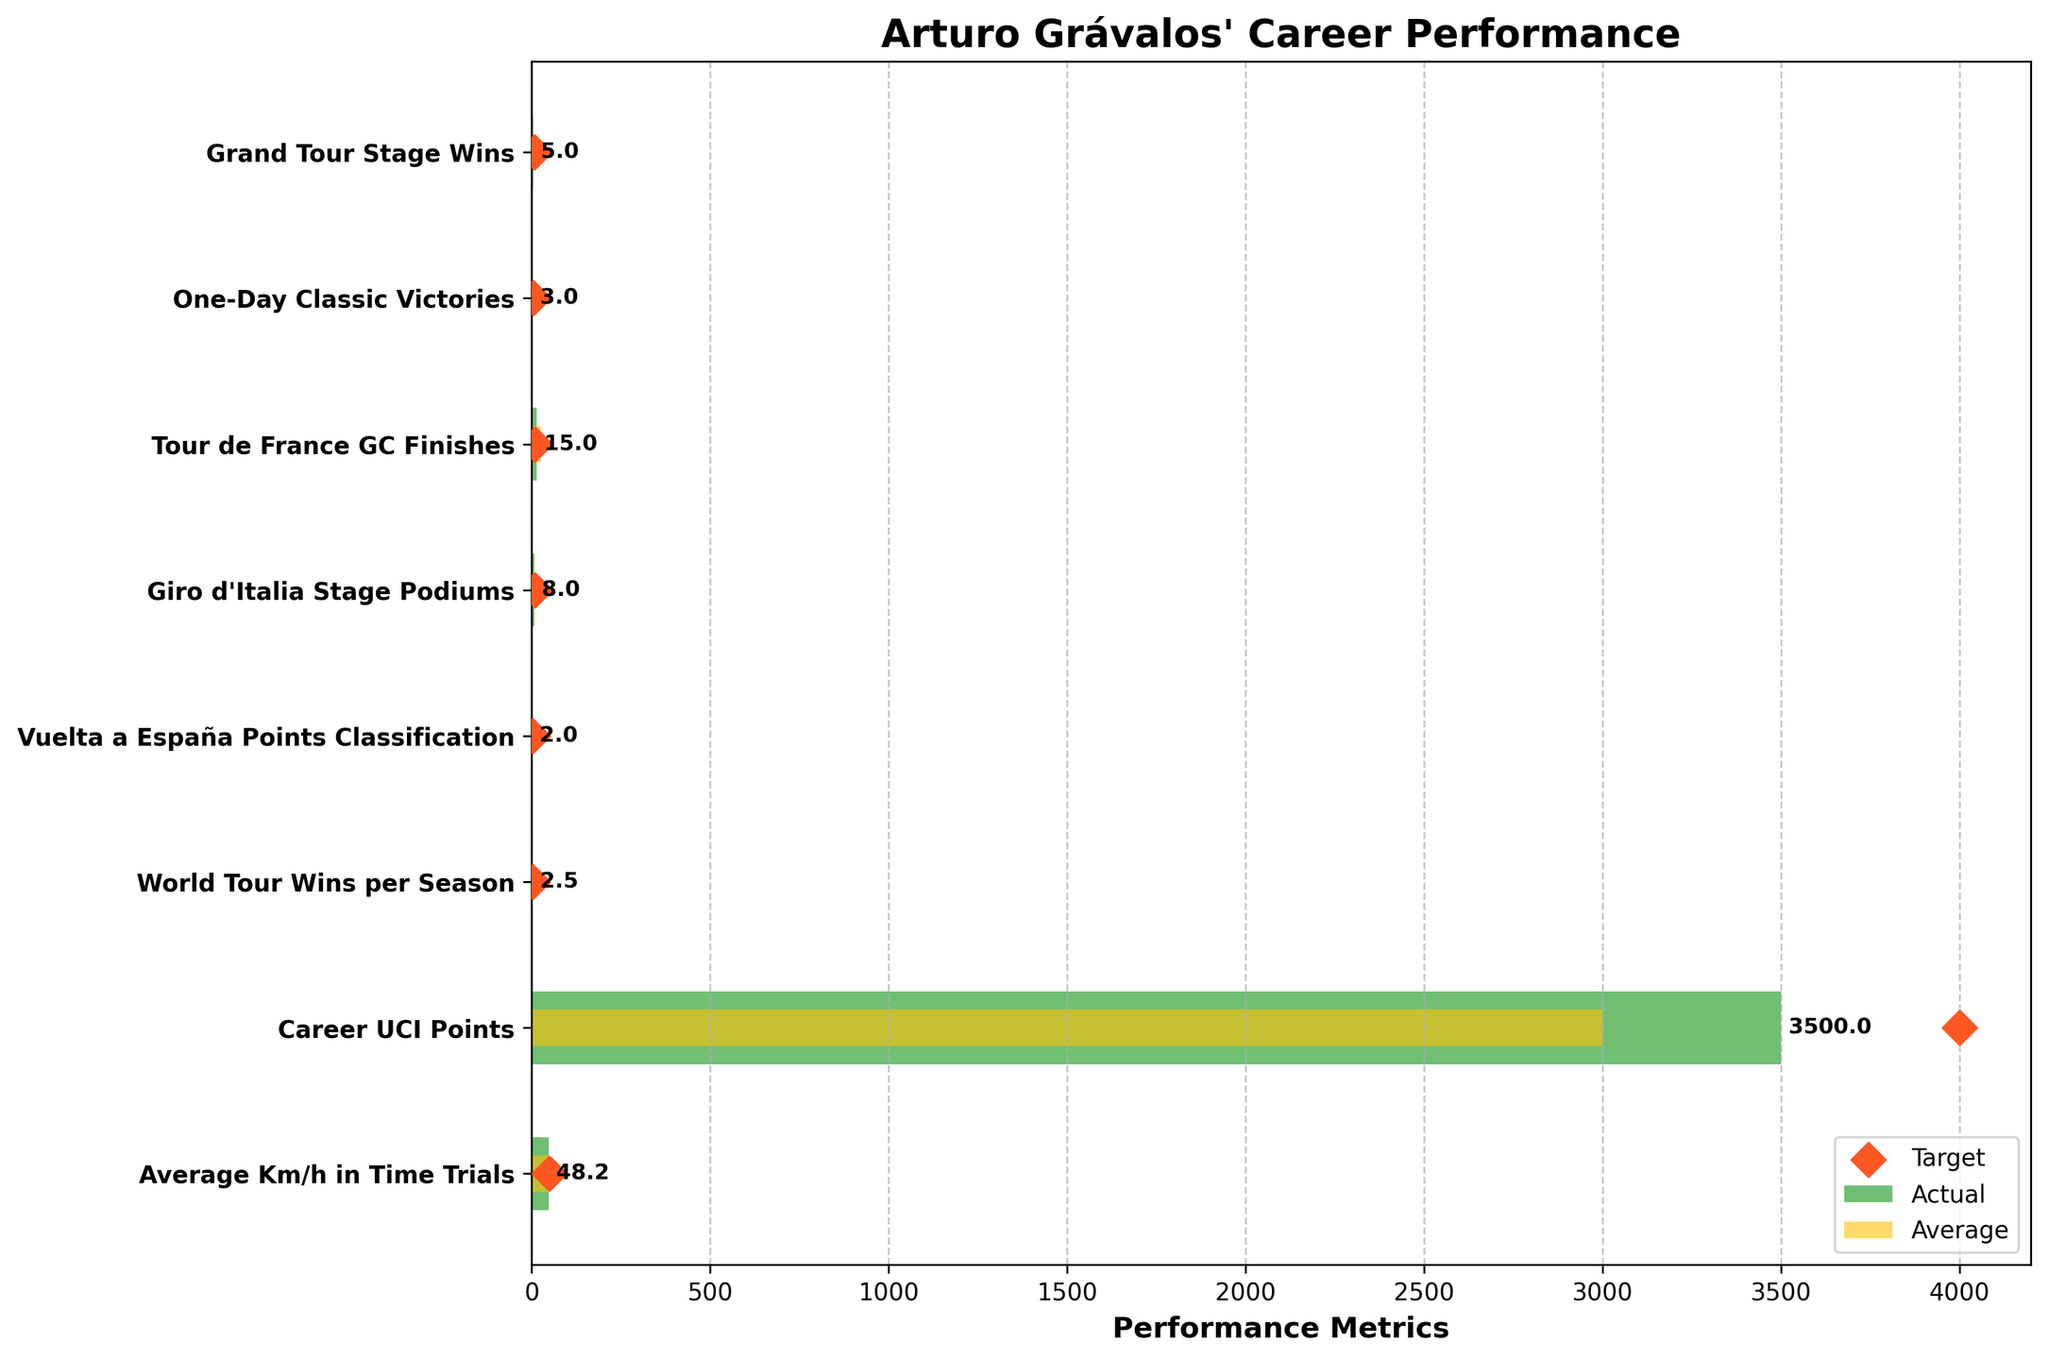what's the title of the figure? The title of the figure is displayed at the top and reads "Arturo Grávalos' Career Performance." Simply reading this text will provide the answer.
Answer: Arturo Grávalos' Career Performance How many performance metrics are shown on the Y-axis? Count the number of categories listed on the Y-axis. The categories appear as the labeled rows on the plot.
Answer: 8 What's the actual number of Grand Tour Stage Wins achieved by Arturo? Locate the "Grand Tour Stage Wins" on the Y-axis and then look at the length of the green bar labeled 'Actual' for this category.
Answer: 5 How many more Giro d'Italia Stage Podiums does Arturo need to reach his target? Look at the actual value (green bar) and the target value (red diamond) for "Giro d'Italia Stage Podiums." Subtract the actual value from the target value (10 - 8).
Answer: 2 In which performance metric did Arturo outperform his average competitor the most? For each category, compare the length of the green bar (Actual) with the yellow bar (Average). The biggest positive difference indicates the most outperformance. This is found by checking visually each of the metrics.
Answer: Tour de France GC Finishes Which metric has the closest actual performance to Arturo's target? Calculate the absolute differences between the actual values (green bars) and target values (red diamonds) for each category. The category with the smallest difference is the answer.
Answer: Average Km/h in Time Trials How many more career UCI points does Arturo need to match his target? Look at the actual value (green bar) and the target value (red diamond) for "Career UCI Points." Subtract the actual value from the target value (4000 - 3500).
Answer: 500 Which category did Arturo exceed his target? Identify the category where the green bar (actual) surpasses the position of the red diamond (target). Scan through all categories to determine this.
Answer: None What is the difference between Arturo’s actual points and his average competitor’s points in Vuelta a España Points Classification? In the "Vuelta a España Points Classification" category, subtract the Average (yellow bar) from the Actual (green bar) values (2 - 1).
Answer: 1 Does Arturo meet his target in World Tour Wins per Season? Compare the green bar (Actual value) to the red diamond (Target value) in the "World Tour Wins per Season" category. If the green bar doesn't reach the red diamond, the target isn't met.
Answer: No 